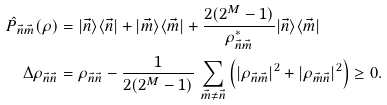<formula> <loc_0><loc_0><loc_500><loc_500>\hat { P } _ { \vec { n } \vec { m } } ( \rho ) & = | \vec { n } \rangle \langle \vec { n } | + | \vec { m } \rangle \langle \vec { m } | + \frac { 2 ( 2 ^ { M } - 1 ) } { \rho _ { \vec { n } \vec { m } } ^ { * } } | \vec { n } \rangle \langle \vec { m } | \\ \Delta \rho _ { \vec { n } \vec { n } } & = \rho _ { \vec { n } \vec { n } } - \frac { 1 } { 2 ( 2 ^ { M } - 1 ) } \, \sum _ { \vec { m } \ne \vec { n } } \left ( | \rho _ { \vec { n } \vec { m } } | ^ { 2 } + | \rho _ { \vec { m } \vec { n } } | ^ { 2 } \right ) \geq 0 .</formula> 